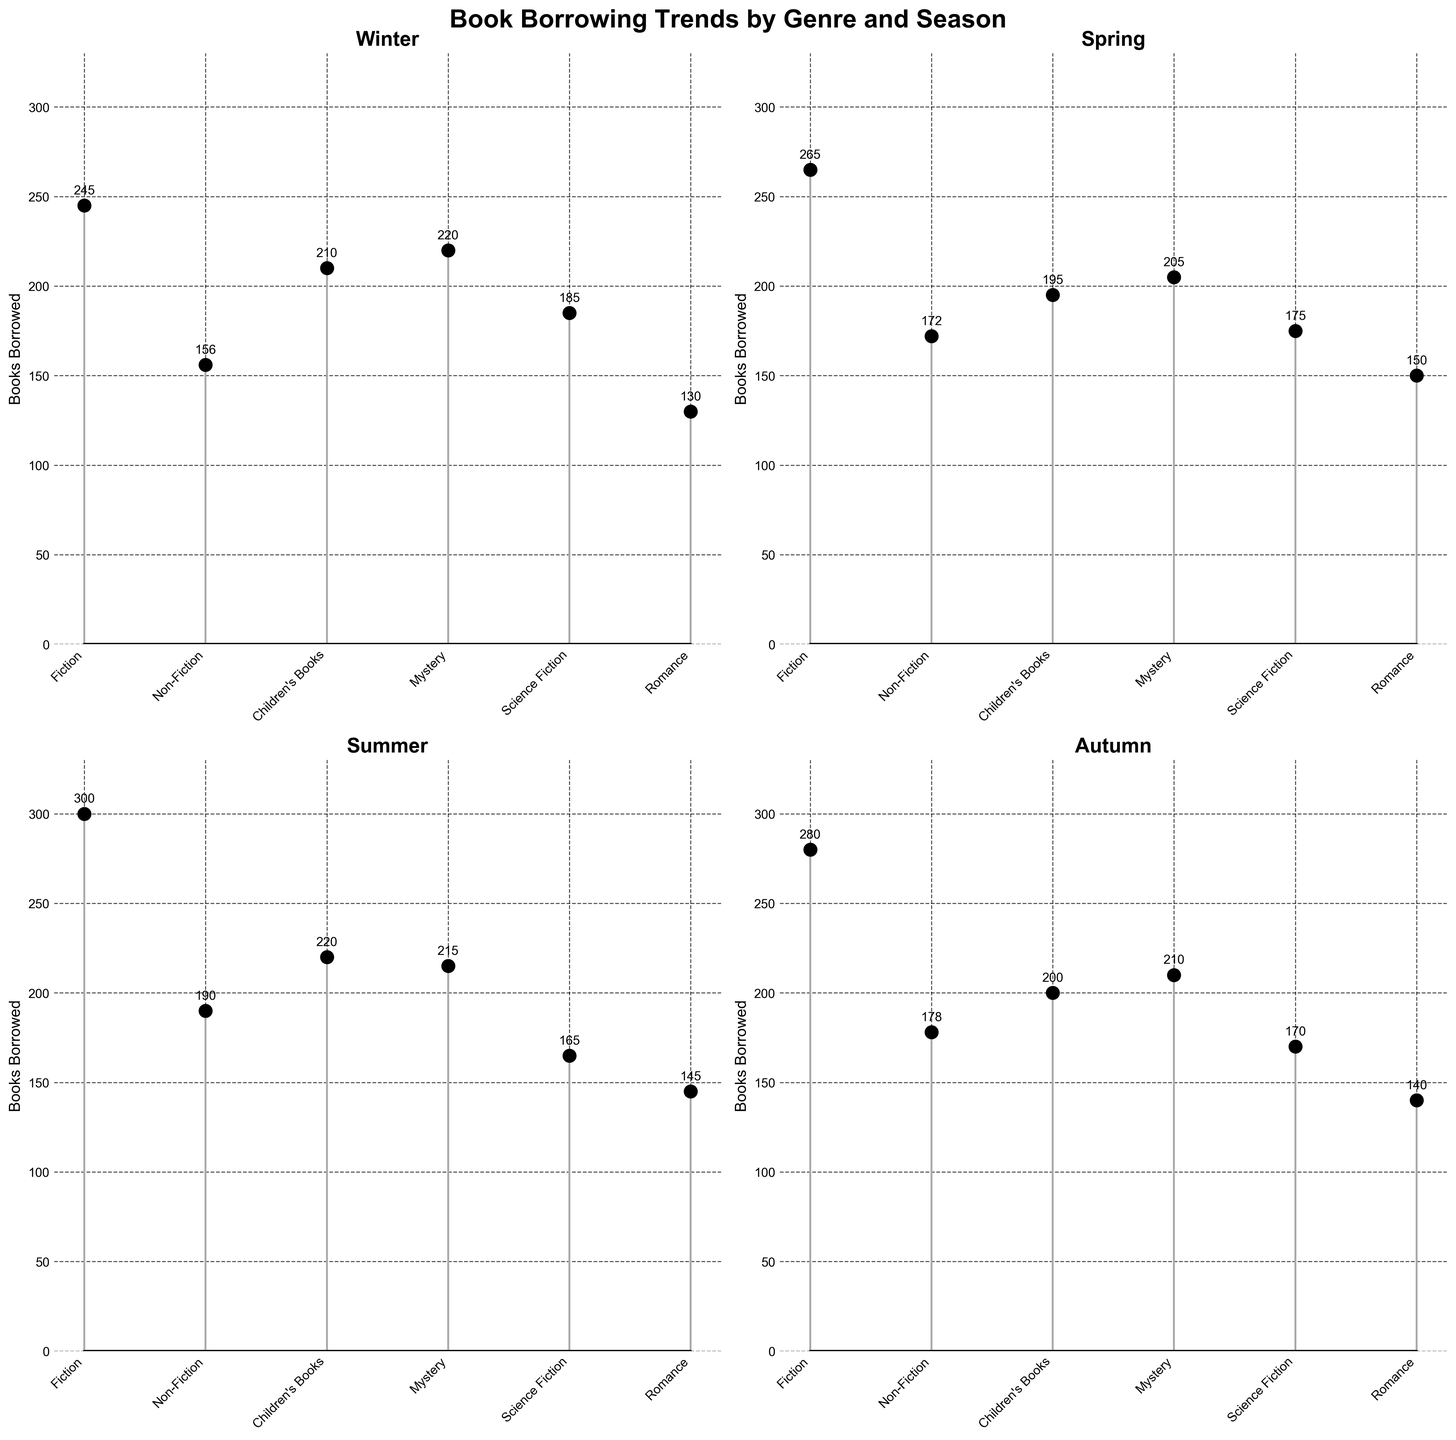What is the title of the figure? The title is usually placed at the top of the figure.
Answer: Book Borrowing Trends by Genre and Season How many genres are represented in each subplot? By counting the unique labels on the x-axis of any subplot, you can determine the number of genres.
Answer: 6 Which season had the highest number of Fiction books borrowed? Look at the stems corresponding to Fiction in each of the seasonal subplots and find the tallest one.
Answer: Summer Which genre had the least number of books borrowed during Spring? Look at the heights of the stems in the Spring subplot and identify the shortest one.
Answer: Children's Books What is the total number of books borrowed in Winter for all genres combined? Add the number of books borrowed for each genre in the Winter subplot (245 + 156 + 210 + 220 + 185 + 130).
Answer: 1146 What is the difference in the number of Non-Fiction books borrowed between Summer and Autumn? Find the height of the Non-Fiction stems in Summer and Autumn, then compute the difference (190 - 178).
Answer: 12 Among all seasons, which one had the most consistent number of books borrowed across all genres? Visually inspect the subplots to see which one has stem heights that are closest to each other across all genres.
Answer: Autumn Which genre tends to see an increase in the number of books borrowed as the seasons progress from Winter to Autumn? Inspect the stems for each genre across the subplots and determine if there is a general upward trend.
Answer: Fiction Which season had the least number of books borrowed for Romance genre? Compare the heights of the stems for Romance across each of the subplots and find the shortest one.
Answer: Winter 